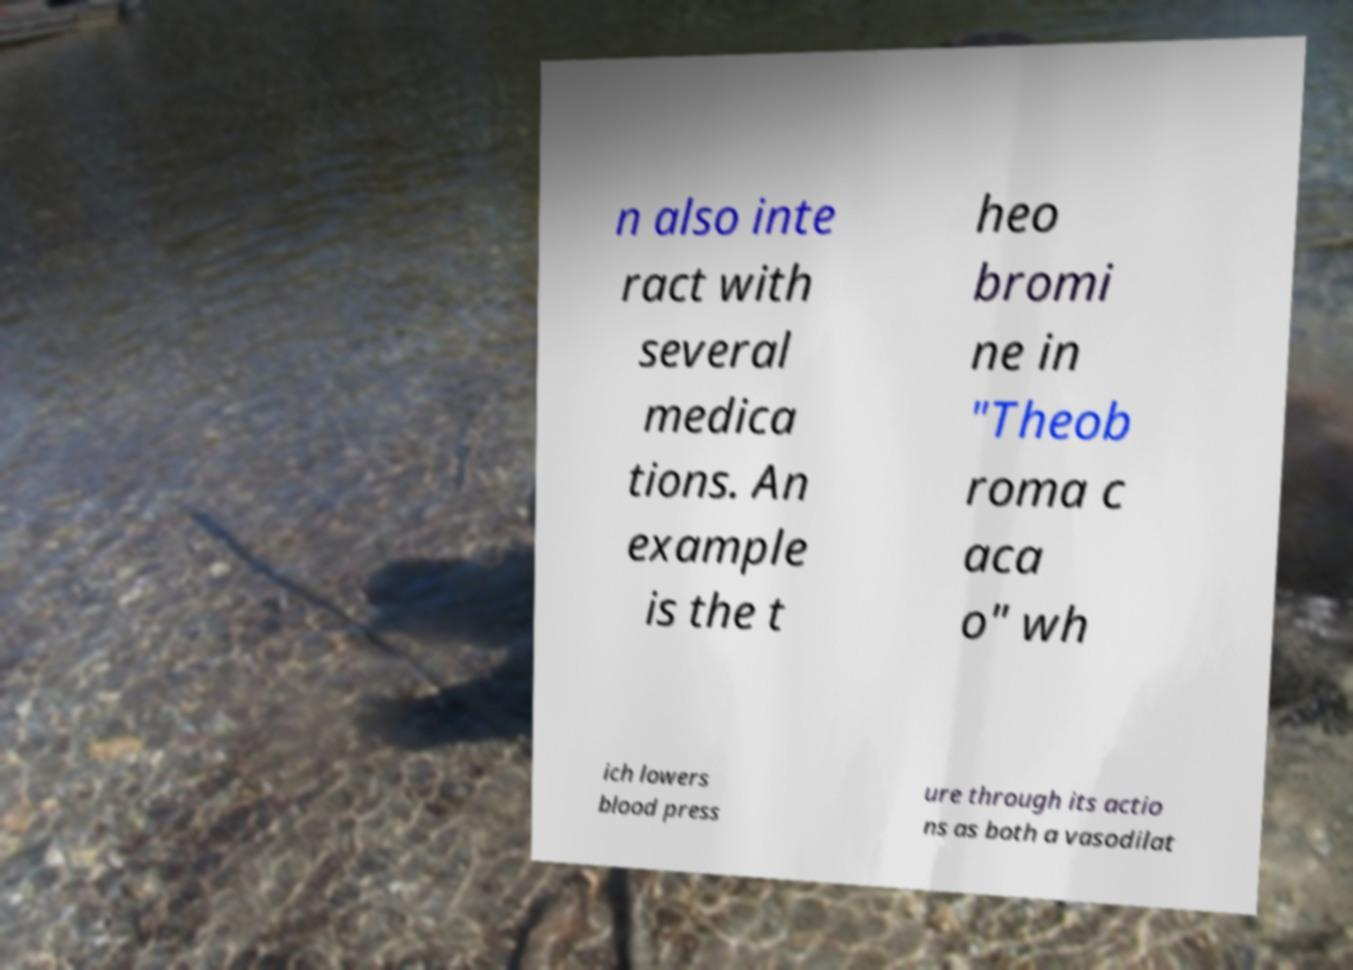Could you assist in decoding the text presented in this image and type it out clearly? n also inte ract with several medica tions. An example is the t heo bromi ne in "Theob roma c aca o" wh ich lowers blood press ure through its actio ns as both a vasodilat 